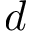<formula> <loc_0><loc_0><loc_500><loc_500>d</formula> 